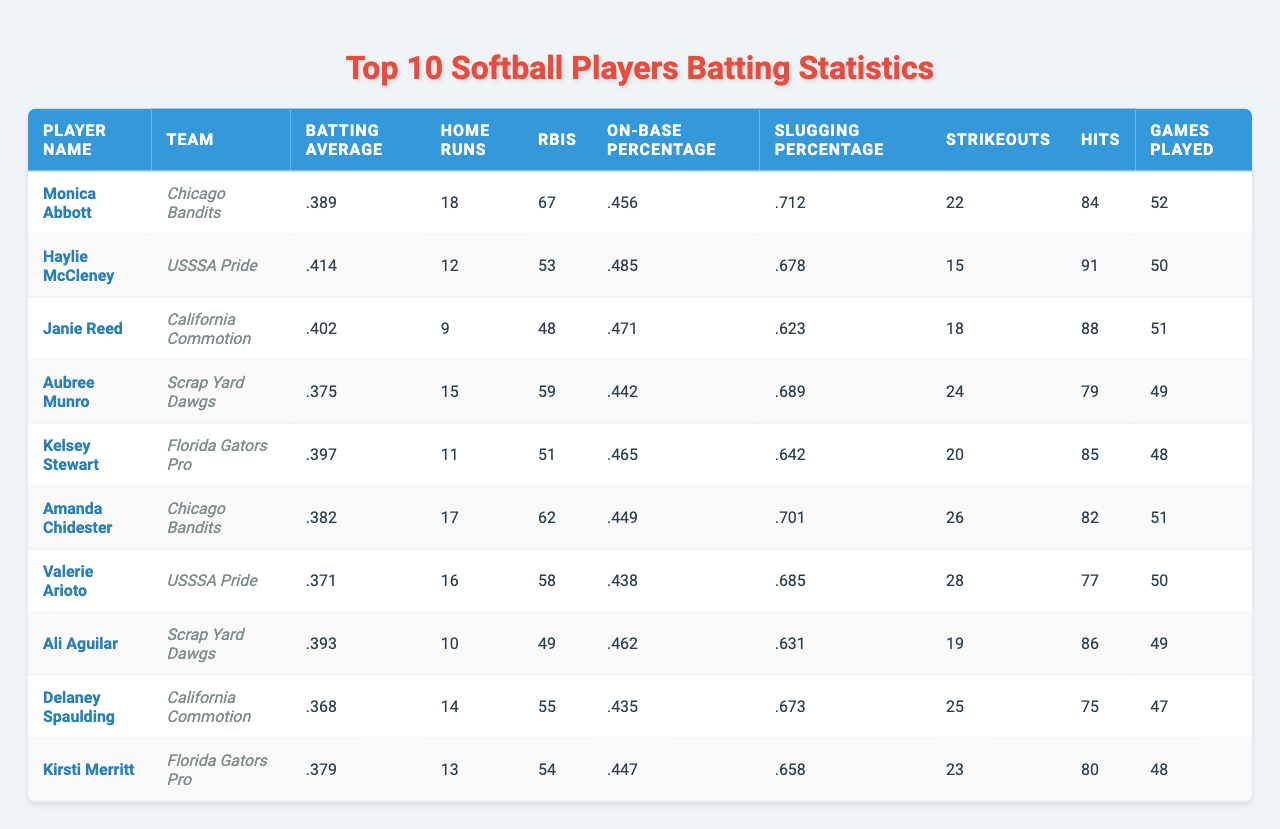What is the batting average of Haylie McCleney? According to the table, Haylie McCleney's batting average is listed directly under her name. The value shown is .414.
Answer: .414 Which player has the highest on-base percentage? To find the highest on-base percentage, we compare the values in the "On-Base Percentage" column. Haylie McCleney has the highest value at .485.
Answer: Haylie McCleney How many home runs did Amanda Chidester hit? Amanda Chidester's number of home runs is in the "Home Runs" column next to her name. The number is 17.
Answer: 17 What is the average number of RBIs for the players listed? First, we sum the RBIs: 67 + 53 + 48 + 59 + 51 + 62 + 58 + 49 + 55 + 54 =  49. The sum of the 10 players' RBIs is 54.9 and then to find the average, we divide by the number of players (10), which gives us 54.9/10 = 54.9.
Answer: 54.9 Does Kelsey Stewart have a higher slugging percentage than Janie Reed? We need to compare the "Slugging Percentage" values. Kelsey Stewart's is .642, while Janie Reed's is .623. Since .642 is greater than .623, Kelsey Stewart does have a higher slugging percentage.
Answer: Yes How many more hits did Monica Abbott get than Delaney Spaulding? To find the difference in hits, we refer to the "Hits" column. Monica Abbott has 84 hits, and Delaney Spaulding has 75 hits. The difference is 84 - 75 = 9.
Answer: 9 What is the total number of strikeouts for all players combined? We sum the strikeouts from the "Strikeouts" column: 22 + 15 + 18 + 24 + 20 + 26 + 28 + 19 + 25 + 23 = 23. The total is 226.
Answer: 226 Which player has the lowest batting average? We need to compare the batting averages listed in the "Batting Average" column. The lowest value is .368 from Delaney Spaulding.
Answer: Delaney Spaulding What percentage of games played did Monica Abbott win based on her RBIs? To find this, we would use the following ratio: RBIs (67) divided by Games Played (52). This gives 67/52 = 1.288, which means she averages 1.288 RBIs per game.
Answer: 1.288 Is there any player who had more than 60 RBIs? By checking the "RBIs" column, we see that Monica Abbott (67), Amanda Chidester (62), and Valerie Arioto (58) all had more than 60 RBIs. So, the answer is yes.
Answer: Yes 